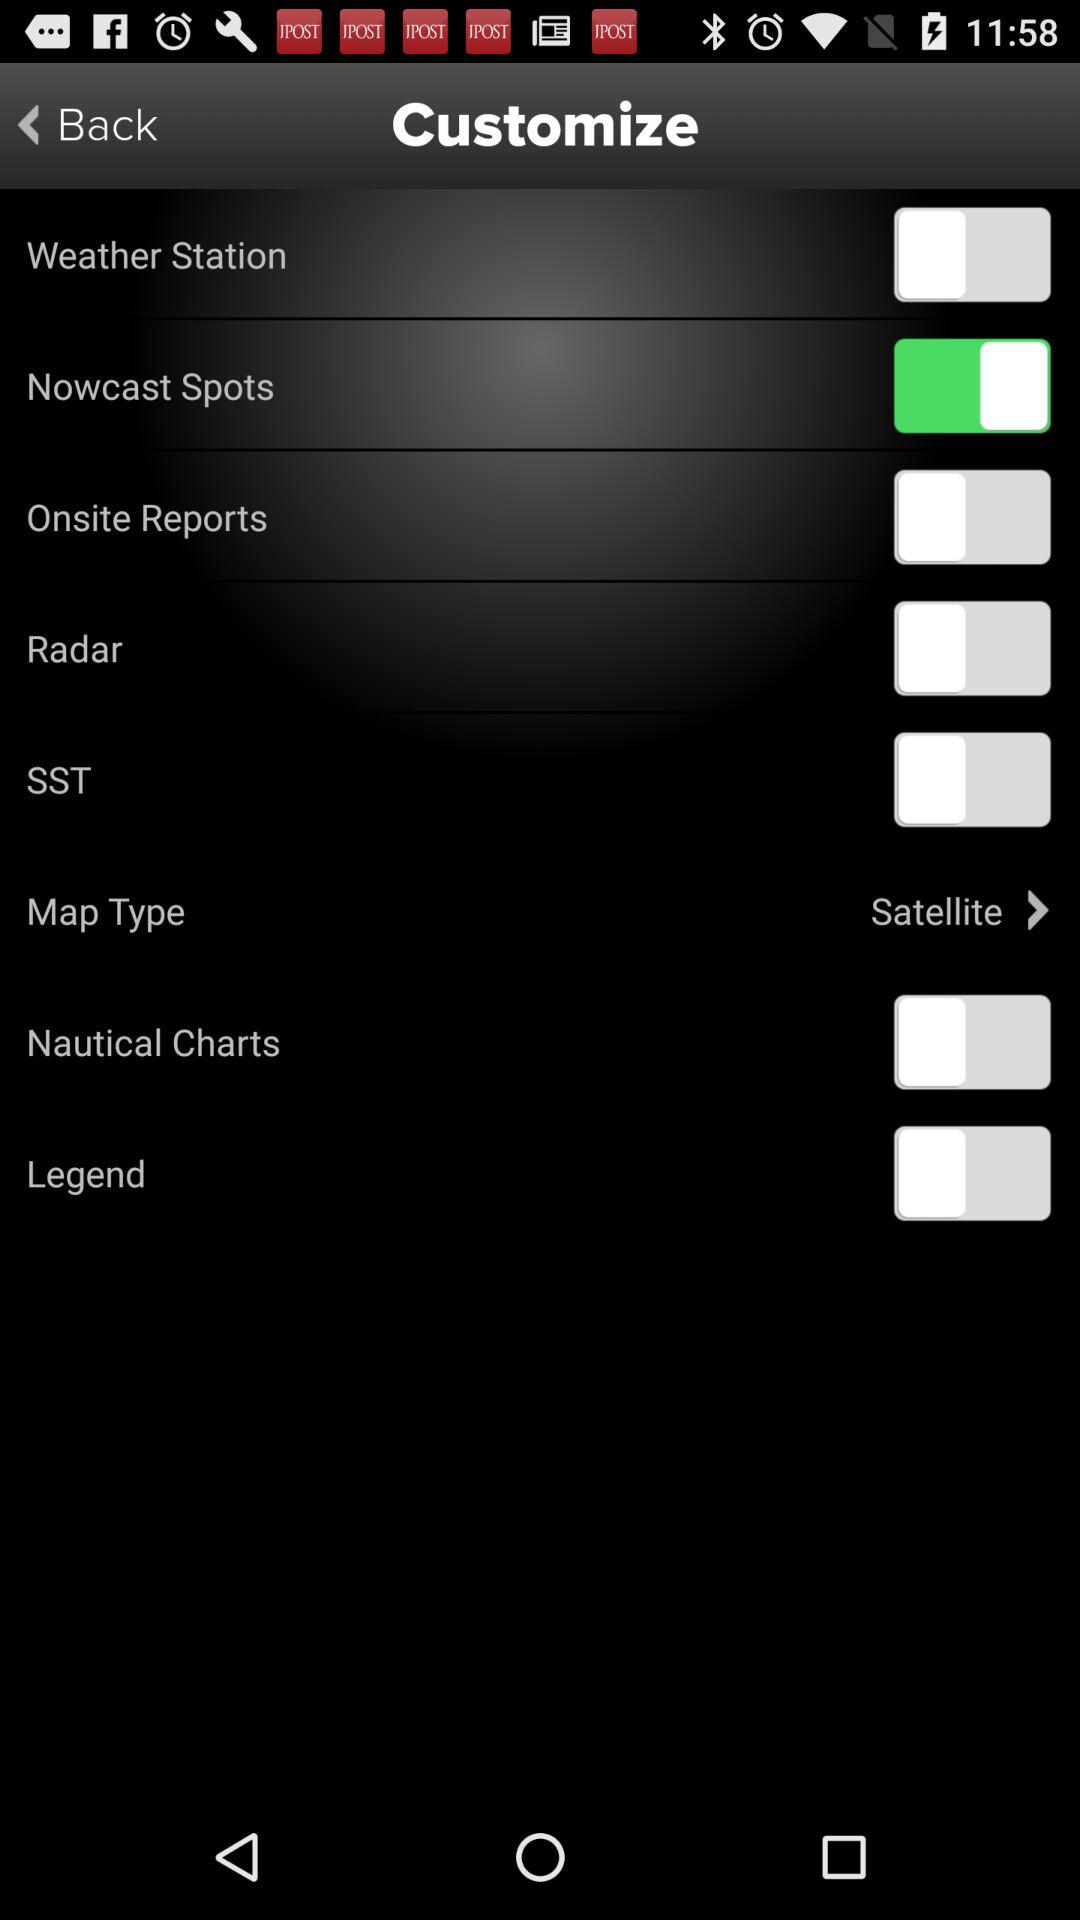What is the status of "Nowcast Spots"? The status is "on". 